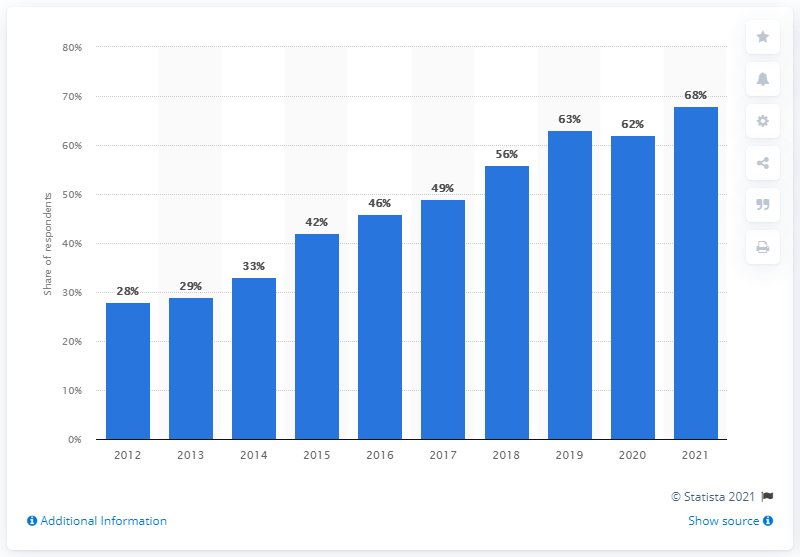Mention a couple of crucial points in this snapshot. In 2021, the highest number of people used smartphones to access news. 